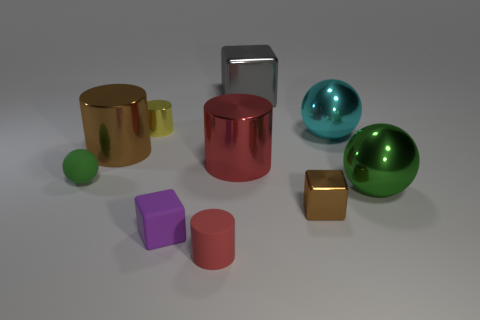What colors are the spheres in the image? The spheres in the image are teal, lime green, and a reflective silver-like color. 